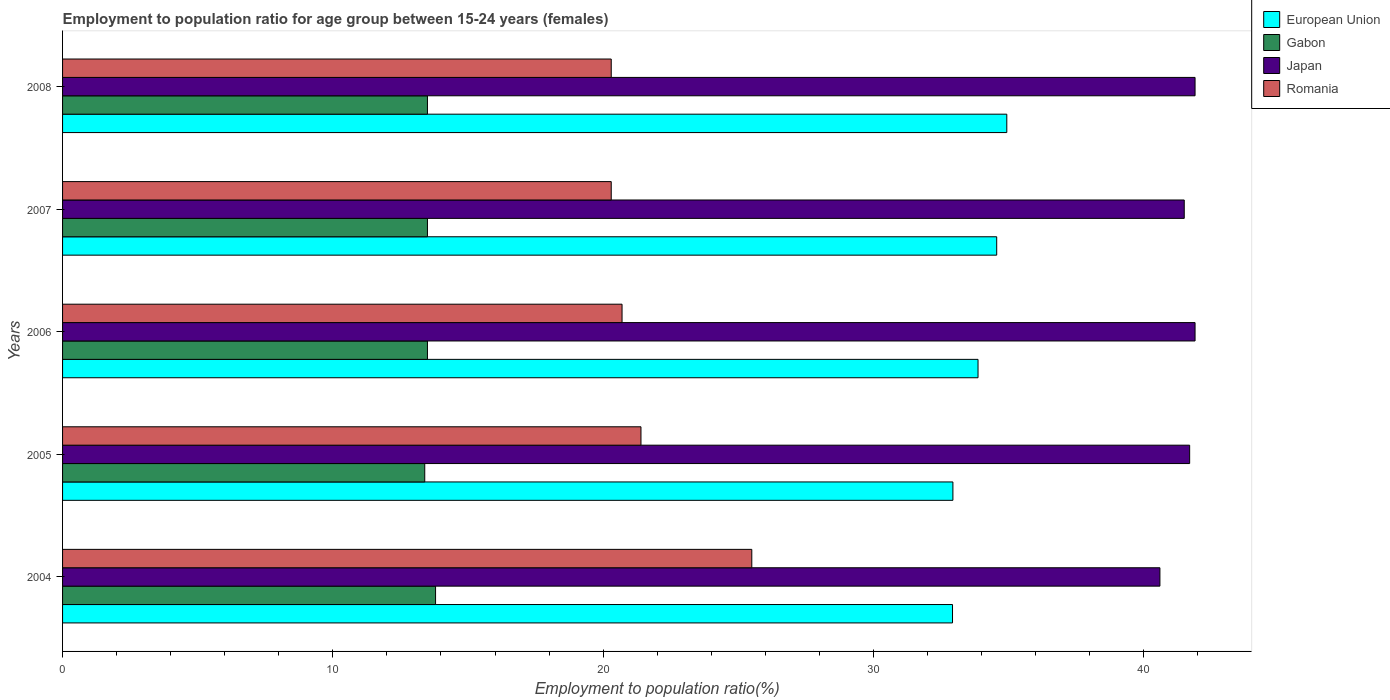How many bars are there on the 5th tick from the top?
Your answer should be very brief. 4. What is the employment to population ratio in Romania in 2004?
Offer a very short reply. 25.5. Across all years, what is the maximum employment to population ratio in Japan?
Provide a short and direct response. 41.9. Across all years, what is the minimum employment to population ratio in Romania?
Keep it short and to the point. 20.3. What is the total employment to population ratio in Romania in the graph?
Offer a very short reply. 108.2. What is the difference between the employment to population ratio in European Union in 2006 and that in 2008?
Offer a very short reply. -1.06. What is the difference between the employment to population ratio in Romania in 2008 and the employment to population ratio in European Union in 2007?
Your response must be concise. -14.26. What is the average employment to population ratio in Romania per year?
Offer a very short reply. 21.64. What is the ratio of the employment to population ratio in European Union in 2005 to that in 2007?
Your answer should be compact. 0.95. Is the employment to population ratio in Japan in 2004 less than that in 2008?
Your answer should be compact. Yes. What is the difference between the highest and the second highest employment to population ratio in Gabon?
Provide a short and direct response. 0.3. What is the difference between the highest and the lowest employment to population ratio in Gabon?
Give a very brief answer. 0.4. In how many years, is the employment to population ratio in Romania greater than the average employment to population ratio in Romania taken over all years?
Your answer should be compact. 1. Is the sum of the employment to population ratio in Japan in 2005 and 2007 greater than the maximum employment to population ratio in European Union across all years?
Offer a terse response. Yes. Is it the case that in every year, the sum of the employment to population ratio in Japan and employment to population ratio in Romania is greater than the sum of employment to population ratio in European Union and employment to population ratio in Gabon?
Make the answer very short. Yes. What does the 3rd bar from the top in 2004 represents?
Make the answer very short. Gabon. What does the 4th bar from the bottom in 2004 represents?
Keep it short and to the point. Romania. Is it the case that in every year, the sum of the employment to population ratio in Romania and employment to population ratio in Gabon is greater than the employment to population ratio in European Union?
Give a very brief answer. No. How many bars are there?
Give a very brief answer. 20. Does the graph contain any zero values?
Ensure brevity in your answer.  No. Does the graph contain grids?
Provide a short and direct response. No. Where does the legend appear in the graph?
Provide a succinct answer. Top right. How many legend labels are there?
Provide a short and direct response. 4. How are the legend labels stacked?
Your answer should be very brief. Vertical. What is the title of the graph?
Provide a short and direct response. Employment to population ratio for age group between 15-24 years (females). Does "Haiti" appear as one of the legend labels in the graph?
Make the answer very short. No. What is the label or title of the X-axis?
Ensure brevity in your answer.  Employment to population ratio(%). What is the Employment to population ratio(%) of European Union in 2004?
Your response must be concise. 32.93. What is the Employment to population ratio(%) in Gabon in 2004?
Provide a short and direct response. 13.8. What is the Employment to population ratio(%) in Japan in 2004?
Your answer should be very brief. 40.6. What is the Employment to population ratio(%) of European Union in 2005?
Provide a short and direct response. 32.94. What is the Employment to population ratio(%) of Gabon in 2005?
Offer a very short reply. 13.4. What is the Employment to population ratio(%) of Japan in 2005?
Ensure brevity in your answer.  41.7. What is the Employment to population ratio(%) in Romania in 2005?
Your answer should be very brief. 21.4. What is the Employment to population ratio(%) of European Union in 2006?
Provide a succinct answer. 33.87. What is the Employment to population ratio(%) of Japan in 2006?
Your answer should be very brief. 41.9. What is the Employment to population ratio(%) in Romania in 2006?
Provide a succinct answer. 20.7. What is the Employment to population ratio(%) in European Union in 2007?
Your answer should be compact. 34.56. What is the Employment to population ratio(%) in Gabon in 2007?
Offer a terse response. 13.5. What is the Employment to population ratio(%) of Japan in 2007?
Make the answer very short. 41.5. What is the Employment to population ratio(%) of Romania in 2007?
Provide a succinct answer. 20.3. What is the Employment to population ratio(%) of European Union in 2008?
Offer a very short reply. 34.93. What is the Employment to population ratio(%) in Gabon in 2008?
Make the answer very short. 13.5. What is the Employment to population ratio(%) of Japan in 2008?
Offer a terse response. 41.9. What is the Employment to population ratio(%) of Romania in 2008?
Make the answer very short. 20.3. Across all years, what is the maximum Employment to population ratio(%) in European Union?
Ensure brevity in your answer.  34.93. Across all years, what is the maximum Employment to population ratio(%) in Gabon?
Provide a succinct answer. 13.8. Across all years, what is the maximum Employment to population ratio(%) of Japan?
Your answer should be compact. 41.9. Across all years, what is the minimum Employment to population ratio(%) in European Union?
Provide a succinct answer. 32.93. Across all years, what is the minimum Employment to population ratio(%) of Gabon?
Offer a terse response. 13.4. Across all years, what is the minimum Employment to population ratio(%) of Japan?
Ensure brevity in your answer.  40.6. Across all years, what is the minimum Employment to population ratio(%) of Romania?
Provide a succinct answer. 20.3. What is the total Employment to population ratio(%) of European Union in the graph?
Provide a short and direct response. 169.23. What is the total Employment to population ratio(%) of Gabon in the graph?
Your response must be concise. 67.7. What is the total Employment to population ratio(%) of Japan in the graph?
Offer a very short reply. 207.6. What is the total Employment to population ratio(%) in Romania in the graph?
Ensure brevity in your answer.  108.2. What is the difference between the Employment to population ratio(%) in European Union in 2004 and that in 2005?
Offer a terse response. -0.01. What is the difference between the Employment to population ratio(%) in Gabon in 2004 and that in 2005?
Your response must be concise. 0.4. What is the difference between the Employment to population ratio(%) of Japan in 2004 and that in 2005?
Ensure brevity in your answer.  -1.1. What is the difference between the Employment to population ratio(%) in European Union in 2004 and that in 2006?
Offer a very short reply. -0.94. What is the difference between the Employment to population ratio(%) of Gabon in 2004 and that in 2006?
Your answer should be very brief. 0.3. What is the difference between the Employment to population ratio(%) in Japan in 2004 and that in 2006?
Your response must be concise. -1.3. What is the difference between the Employment to population ratio(%) in European Union in 2004 and that in 2007?
Provide a short and direct response. -1.64. What is the difference between the Employment to population ratio(%) in Romania in 2004 and that in 2007?
Make the answer very short. 5.2. What is the difference between the Employment to population ratio(%) of European Union in 2004 and that in 2008?
Keep it short and to the point. -2.01. What is the difference between the Employment to population ratio(%) of Gabon in 2004 and that in 2008?
Offer a very short reply. 0.3. What is the difference between the Employment to population ratio(%) of European Union in 2005 and that in 2006?
Give a very brief answer. -0.93. What is the difference between the Employment to population ratio(%) of Japan in 2005 and that in 2006?
Offer a terse response. -0.2. What is the difference between the Employment to population ratio(%) in European Union in 2005 and that in 2007?
Your response must be concise. -1.62. What is the difference between the Employment to population ratio(%) of Japan in 2005 and that in 2007?
Keep it short and to the point. 0.2. What is the difference between the Employment to population ratio(%) of Romania in 2005 and that in 2007?
Offer a terse response. 1.1. What is the difference between the Employment to population ratio(%) of European Union in 2005 and that in 2008?
Provide a short and direct response. -1.99. What is the difference between the Employment to population ratio(%) of Romania in 2005 and that in 2008?
Ensure brevity in your answer.  1.1. What is the difference between the Employment to population ratio(%) of European Union in 2006 and that in 2007?
Offer a very short reply. -0.69. What is the difference between the Employment to population ratio(%) in Japan in 2006 and that in 2007?
Give a very brief answer. 0.4. What is the difference between the Employment to population ratio(%) of Romania in 2006 and that in 2007?
Your answer should be very brief. 0.4. What is the difference between the Employment to population ratio(%) in European Union in 2006 and that in 2008?
Your answer should be compact. -1.06. What is the difference between the Employment to population ratio(%) of Japan in 2006 and that in 2008?
Keep it short and to the point. 0. What is the difference between the Employment to population ratio(%) of European Union in 2007 and that in 2008?
Make the answer very short. -0.37. What is the difference between the Employment to population ratio(%) in Gabon in 2007 and that in 2008?
Offer a very short reply. 0. What is the difference between the Employment to population ratio(%) of Japan in 2007 and that in 2008?
Give a very brief answer. -0.4. What is the difference between the Employment to population ratio(%) in Romania in 2007 and that in 2008?
Keep it short and to the point. 0. What is the difference between the Employment to population ratio(%) of European Union in 2004 and the Employment to population ratio(%) of Gabon in 2005?
Keep it short and to the point. 19.53. What is the difference between the Employment to population ratio(%) in European Union in 2004 and the Employment to population ratio(%) in Japan in 2005?
Your answer should be compact. -8.77. What is the difference between the Employment to population ratio(%) in European Union in 2004 and the Employment to population ratio(%) in Romania in 2005?
Offer a very short reply. 11.53. What is the difference between the Employment to population ratio(%) of Gabon in 2004 and the Employment to population ratio(%) of Japan in 2005?
Provide a succinct answer. -27.9. What is the difference between the Employment to population ratio(%) in Gabon in 2004 and the Employment to population ratio(%) in Romania in 2005?
Provide a short and direct response. -7.6. What is the difference between the Employment to population ratio(%) in Japan in 2004 and the Employment to population ratio(%) in Romania in 2005?
Make the answer very short. 19.2. What is the difference between the Employment to population ratio(%) of European Union in 2004 and the Employment to population ratio(%) of Gabon in 2006?
Provide a succinct answer. 19.43. What is the difference between the Employment to population ratio(%) in European Union in 2004 and the Employment to population ratio(%) in Japan in 2006?
Provide a short and direct response. -8.97. What is the difference between the Employment to population ratio(%) in European Union in 2004 and the Employment to population ratio(%) in Romania in 2006?
Provide a succinct answer. 12.23. What is the difference between the Employment to population ratio(%) of Gabon in 2004 and the Employment to population ratio(%) of Japan in 2006?
Ensure brevity in your answer.  -28.1. What is the difference between the Employment to population ratio(%) of Japan in 2004 and the Employment to population ratio(%) of Romania in 2006?
Offer a very short reply. 19.9. What is the difference between the Employment to population ratio(%) of European Union in 2004 and the Employment to population ratio(%) of Gabon in 2007?
Give a very brief answer. 19.43. What is the difference between the Employment to population ratio(%) of European Union in 2004 and the Employment to population ratio(%) of Japan in 2007?
Give a very brief answer. -8.57. What is the difference between the Employment to population ratio(%) in European Union in 2004 and the Employment to population ratio(%) in Romania in 2007?
Give a very brief answer. 12.63. What is the difference between the Employment to population ratio(%) of Gabon in 2004 and the Employment to population ratio(%) of Japan in 2007?
Make the answer very short. -27.7. What is the difference between the Employment to population ratio(%) in Japan in 2004 and the Employment to population ratio(%) in Romania in 2007?
Provide a short and direct response. 20.3. What is the difference between the Employment to population ratio(%) of European Union in 2004 and the Employment to population ratio(%) of Gabon in 2008?
Provide a succinct answer. 19.43. What is the difference between the Employment to population ratio(%) in European Union in 2004 and the Employment to population ratio(%) in Japan in 2008?
Offer a terse response. -8.97. What is the difference between the Employment to population ratio(%) of European Union in 2004 and the Employment to population ratio(%) of Romania in 2008?
Offer a terse response. 12.63. What is the difference between the Employment to population ratio(%) of Gabon in 2004 and the Employment to population ratio(%) of Japan in 2008?
Offer a terse response. -28.1. What is the difference between the Employment to population ratio(%) in Japan in 2004 and the Employment to population ratio(%) in Romania in 2008?
Your answer should be compact. 20.3. What is the difference between the Employment to population ratio(%) of European Union in 2005 and the Employment to population ratio(%) of Gabon in 2006?
Give a very brief answer. 19.44. What is the difference between the Employment to population ratio(%) of European Union in 2005 and the Employment to population ratio(%) of Japan in 2006?
Give a very brief answer. -8.96. What is the difference between the Employment to population ratio(%) in European Union in 2005 and the Employment to population ratio(%) in Romania in 2006?
Ensure brevity in your answer.  12.24. What is the difference between the Employment to population ratio(%) in Gabon in 2005 and the Employment to population ratio(%) in Japan in 2006?
Offer a terse response. -28.5. What is the difference between the Employment to population ratio(%) in Japan in 2005 and the Employment to population ratio(%) in Romania in 2006?
Make the answer very short. 21. What is the difference between the Employment to population ratio(%) of European Union in 2005 and the Employment to population ratio(%) of Gabon in 2007?
Your answer should be very brief. 19.44. What is the difference between the Employment to population ratio(%) of European Union in 2005 and the Employment to population ratio(%) of Japan in 2007?
Provide a short and direct response. -8.56. What is the difference between the Employment to population ratio(%) of European Union in 2005 and the Employment to population ratio(%) of Romania in 2007?
Offer a very short reply. 12.64. What is the difference between the Employment to population ratio(%) in Gabon in 2005 and the Employment to population ratio(%) in Japan in 2007?
Your response must be concise. -28.1. What is the difference between the Employment to population ratio(%) in Japan in 2005 and the Employment to population ratio(%) in Romania in 2007?
Provide a short and direct response. 21.4. What is the difference between the Employment to population ratio(%) of European Union in 2005 and the Employment to population ratio(%) of Gabon in 2008?
Give a very brief answer. 19.44. What is the difference between the Employment to population ratio(%) in European Union in 2005 and the Employment to population ratio(%) in Japan in 2008?
Ensure brevity in your answer.  -8.96. What is the difference between the Employment to population ratio(%) of European Union in 2005 and the Employment to population ratio(%) of Romania in 2008?
Provide a succinct answer. 12.64. What is the difference between the Employment to population ratio(%) in Gabon in 2005 and the Employment to population ratio(%) in Japan in 2008?
Offer a very short reply. -28.5. What is the difference between the Employment to population ratio(%) in Japan in 2005 and the Employment to population ratio(%) in Romania in 2008?
Ensure brevity in your answer.  21.4. What is the difference between the Employment to population ratio(%) in European Union in 2006 and the Employment to population ratio(%) in Gabon in 2007?
Offer a terse response. 20.37. What is the difference between the Employment to population ratio(%) in European Union in 2006 and the Employment to population ratio(%) in Japan in 2007?
Give a very brief answer. -7.63. What is the difference between the Employment to population ratio(%) in European Union in 2006 and the Employment to population ratio(%) in Romania in 2007?
Make the answer very short. 13.57. What is the difference between the Employment to population ratio(%) of Gabon in 2006 and the Employment to population ratio(%) of Japan in 2007?
Your answer should be compact. -28. What is the difference between the Employment to population ratio(%) of Gabon in 2006 and the Employment to population ratio(%) of Romania in 2007?
Provide a succinct answer. -6.8. What is the difference between the Employment to population ratio(%) of Japan in 2006 and the Employment to population ratio(%) of Romania in 2007?
Keep it short and to the point. 21.6. What is the difference between the Employment to population ratio(%) in European Union in 2006 and the Employment to population ratio(%) in Gabon in 2008?
Your answer should be very brief. 20.37. What is the difference between the Employment to population ratio(%) of European Union in 2006 and the Employment to population ratio(%) of Japan in 2008?
Offer a very short reply. -8.03. What is the difference between the Employment to population ratio(%) in European Union in 2006 and the Employment to population ratio(%) in Romania in 2008?
Give a very brief answer. 13.57. What is the difference between the Employment to population ratio(%) in Gabon in 2006 and the Employment to population ratio(%) in Japan in 2008?
Your answer should be very brief. -28.4. What is the difference between the Employment to population ratio(%) in Gabon in 2006 and the Employment to population ratio(%) in Romania in 2008?
Provide a short and direct response. -6.8. What is the difference between the Employment to population ratio(%) in Japan in 2006 and the Employment to population ratio(%) in Romania in 2008?
Ensure brevity in your answer.  21.6. What is the difference between the Employment to population ratio(%) of European Union in 2007 and the Employment to population ratio(%) of Gabon in 2008?
Give a very brief answer. 21.06. What is the difference between the Employment to population ratio(%) in European Union in 2007 and the Employment to population ratio(%) in Japan in 2008?
Provide a short and direct response. -7.34. What is the difference between the Employment to population ratio(%) of European Union in 2007 and the Employment to population ratio(%) of Romania in 2008?
Offer a terse response. 14.26. What is the difference between the Employment to population ratio(%) in Gabon in 2007 and the Employment to population ratio(%) in Japan in 2008?
Your answer should be compact. -28.4. What is the difference between the Employment to population ratio(%) in Japan in 2007 and the Employment to population ratio(%) in Romania in 2008?
Your response must be concise. 21.2. What is the average Employment to population ratio(%) in European Union per year?
Provide a succinct answer. 33.85. What is the average Employment to population ratio(%) of Gabon per year?
Offer a very short reply. 13.54. What is the average Employment to population ratio(%) in Japan per year?
Give a very brief answer. 41.52. What is the average Employment to population ratio(%) in Romania per year?
Give a very brief answer. 21.64. In the year 2004, what is the difference between the Employment to population ratio(%) in European Union and Employment to population ratio(%) in Gabon?
Offer a very short reply. 19.13. In the year 2004, what is the difference between the Employment to population ratio(%) in European Union and Employment to population ratio(%) in Japan?
Your answer should be compact. -7.67. In the year 2004, what is the difference between the Employment to population ratio(%) of European Union and Employment to population ratio(%) of Romania?
Keep it short and to the point. 7.43. In the year 2004, what is the difference between the Employment to population ratio(%) of Gabon and Employment to population ratio(%) of Japan?
Your answer should be very brief. -26.8. In the year 2004, what is the difference between the Employment to population ratio(%) in Gabon and Employment to population ratio(%) in Romania?
Your answer should be compact. -11.7. In the year 2004, what is the difference between the Employment to population ratio(%) of Japan and Employment to population ratio(%) of Romania?
Your response must be concise. 15.1. In the year 2005, what is the difference between the Employment to population ratio(%) of European Union and Employment to population ratio(%) of Gabon?
Give a very brief answer. 19.54. In the year 2005, what is the difference between the Employment to population ratio(%) in European Union and Employment to population ratio(%) in Japan?
Make the answer very short. -8.76. In the year 2005, what is the difference between the Employment to population ratio(%) of European Union and Employment to population ratio(%) of Romania?
Your answer should be very brief. 11.54. In the year 2005, what is the difference between the Employment to population ratio(%) of Gabon and Employment to population ratio(%) of Japan?
Offer a terse response. -28.3. In the year 2005, what is the difference between the Employment to population ratio(%) of Gabon and Employment to population ratio(%) of Romania?
Provide a short and direct response. -8. In the year 2005, what is the difference between the Employment to population ratio(%) in Japan and Employment to population ratio(%) in Romania?
Offer a terse response. 20.3. In the year 2006, what is the difference between the Employment to population ratio(%) of European Union and Employment to population ratio(%) of Gabon?
Keep it short and to the point. 20.37. In the year 2006, what is the difference between the Employment to population ratio(%) of European Union and Employment to population ratio(%) of Japan?
Your answer should be very brief. -8.03. In the year 2006, what is the difference between the Employment to population ratio(%) of European Union and Employment to population ratio(%) of Romania?
Ensure brevity in your answer.  13.17. In the year 2006, what is the difference between the Employment to population ratio(%) in Gabon and Employment to population ratio(%) in Japan?
Make the answer very short. -28.4. In the year 2006, what is the difference between the Employment to population ratio(%) of Japan and Employment to population ratio(%) of Romania?
Offer a very short reply. 21.2. In the year 2007, what is the difference between the Employment to population ratio(%) in European Union and Employment to population ratio(%) in Gabon?
Provide a succinct answer. 21.06. In the year 2007, what is the difference between the Employment to population ratio(%) of European Union and Employment to population ratio(%) of Japan?
Give a very brief answer. -6.94. In the year 2007, what is the difference between the Employment to population ratio(%) in European Union and Employment to population ratio(%) in Romania?
Ensure brevity in your answer.  14.26. In the year 2007, what is the difference between the Employment to population ratio(%) in Gabon and Employment to population ratio(%) in Japan?
Your response must be concise. -28. In the year 2007, what is the difference between the Employment to population ratio(%) in Japan and Employment to population ratio(%) in Romania?
Offer a terse response. 21.2. In the year 2008, what is the difference between the Employment to population ratio(%) in European Union and Employment to population ratio(%) in Gabon?
Your answer should be compact. 21.43. In the year 2008, what is the difference between the Employment to population ratio(%) in European Union and Employment to population ratio(%) in Japan?
Provide a succinct answer. -6.97. In the year 2008, what is the difference between the Employment to population ratio(%) in European Union and Employment to population ratio(%) in Romania?
Give a very brief answer. 14.63. In the year 2008, what is the difference between the Employment to population ratio(%) of Gabon and Employment to population ratio(%) of Japan?
Provide a succinct answer. -28.4. In the year 2008, what is the difference between the Employment to population ratio(%) of Gabon and Employment to population ratio(%) of Romania?
Your answer should be very brief. -6.8. In the year 2008, what is the difference between the Employment to population ratio(%) of Japan and Employment to population ratio(%) of Romania?
Provide a short and direct response. 21.6. What is the ratio of the Employment to population ratio(%) in Gabon in 2004 to that in 2005?
Your answer should be compact. 1.03. What is the ratio of the Employment to population ratio(%) in Japan in 2004 to that in 2005?
Offer a terse response. 0.97. What is the ratio of the Employment to population ratio(%) of Romania in 2004 to that in 2005?
Provide a short and direct response. 1.19. What is the ratio of the Employment to population ratio(%) in European Union in 2004 to that in 2006?
Your response must be concise. 0.97. What is the ratio of the Employment to population ratio(%) in Gabon in 2004 to that in 2006?
Ensure brevity in your answer.  1.02. What is the ratio of the Employment to population ratio(%) in Romania in 2004 to that in 2006?
Offer a terse response. 1.23. What is the ratio of the Employment to population ratio(%) in European Union in 2004 to that in 2007?
Provide a succinct answer. 0.95. What is the ratio of the Employment to population ratio(%) of Gabon in 2004 to that in 2007?
Ensure brevity in your answer.  1.02. What is the ratio of the Employment to population ratio(%) in Japan in 2004 to that in 2007?
Provide a short and direct response. 0.98. What is the ratio of the Employment to population ratio(%) of Romania in 2004 to that in 2007?
Provide a short and direct response. 1.26. What is the ratio of the Employment to population ratio(%) in European Union in 2004 to that in 2008?
Your answer should be compact. 0.94. What is the ratio of the Employment to population ratio(%) in Gabon in 2004 to that in 2008?
Make the answer very short. 1.02. What is the ratio of the Employment to population ratio(%) of Romania in 2004 to that in 2008?
Offer a very short reply. 1.26. What is the ratio of the Employment to population ratio(%) in European Union in 2005 to that in 2006?
Your answer should be very brief. 0.97. What is the ratio of the Employment to population ratio(%) of Gabon in 2005 to that in 2006?
Give a very brief answer. 0.99. What is the ratio of the Employment to population ratio(%) of Japan in 2005 to that in 2006?
Keep it short and to the point. 1. What is the ratio of the Employment to population ratio(%) of Romania in 2005 to that in 2006?
Give a very brief answer. 1.03. What is the ratio of the Employment to population ratio(%) in European Union in 2005 to that in 2007?
Give a very brief answer. 0.95. What is the ratio of the Employment to population ratio(%) of Romania in 2005 to that in 2007?
Keep it short and to the point. 1.05. What is the ratio of the Employment to population ratio(%) in European Union in 2005 to that in 2008?
Provide a succinct answer. 0.94. What is the ratio of the Employment to population ratio(%) of Japan in 2005 to that in 2008?
Your answer should be very brief. 1. What is the ratio of the Employment to population ratio(%) of Romania in 2005 to that in 2008?
Offer a very short reply. 1.05. What is the ratio of the Employment to population ratio(%) of Gabon in 2006 to that in 2007?
Provide a short and direct response. 1. What is the ratio of the Employment to population ratio(%) of Japan in 2006 to that in 2007?
Your response must be concise. 1.01. What is the ratio of the Employment to population ratio(%) of Romania in 2006 to that in 2007?
Your answer should be compact. 1.02. What is the ratio of the Employment to population ratio(%) in European Union in 2006 to that in 2008?
Your answer should be compact. 0.97. What is the ratio of the Employment to population ratio(%) in Gabon in 2006 to that in 2008?
Make the answer very short. 1. What is the ratio of the Employment to population ratio(%) in Romania in 2006 to that in 2008?
Ensure brevity in your answer.  1.02. What is the ratio of the Employment to population ratio(%) in European Union in 2007 to that in 2008?
Give a very brief answer. 0.99. What is the ratio of the Employment to population ratio(%) in Japan in 2007 to that in 2008?
Give a very brief answer. 0.99. What is the ratio of the Employment to population ratio(%) of Romania in 2007 to that in 2008?
Give a very brief answer. 1. What is the difference between the highest and the second highest Employment to population ratio(%) in European Union?
Offer a terse response. 0.37. What is the difference between the highest and the second highest Employment to population ratio(%) of Romania?
Ensure brevity in your answer.  4.1. What is the difference between the highest and the lowest Employment to population ratio(%) of European Union?
Provide a succinct answer. 2.01. What is the difference between the highest and the lowest Employment to population ratio(%) in Gabon?
Your response must be concise. 0.4. What is the difference between the highest and the lowest Employment to population ratio(%) of Japan?
Give a very brief answer. 1.3. 